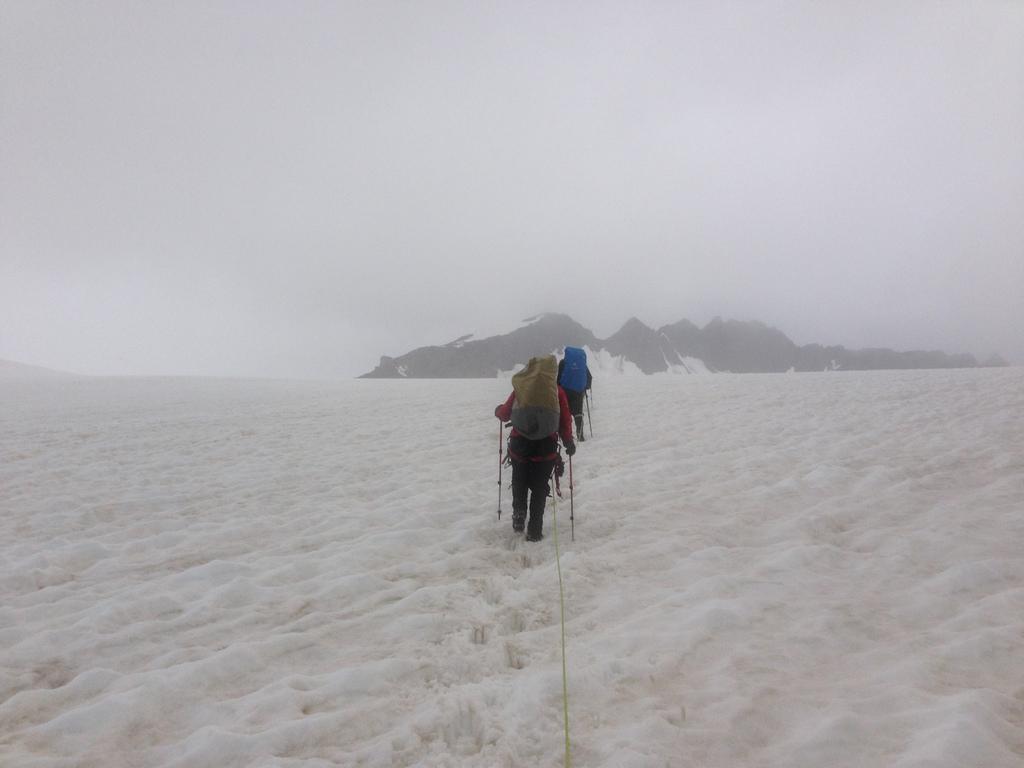Could you give a brief overview of what you see in this image? In this image in the center there are two persons who are walking and they are wearing bags, at the bottom there is snow. In the background there are mountains. 